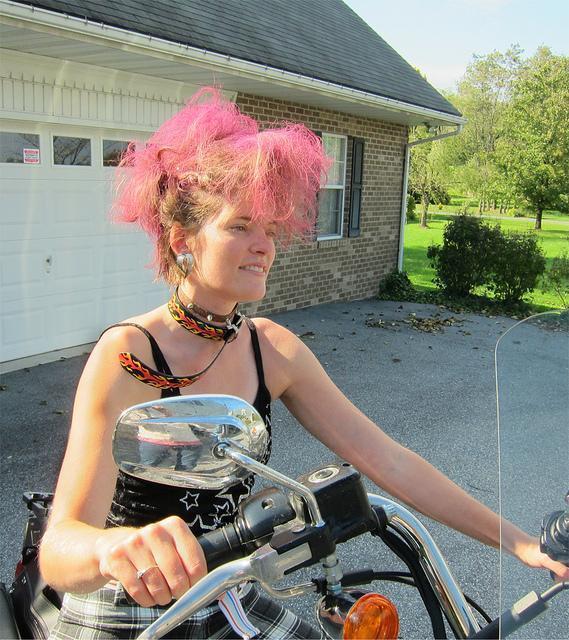How many of the boats in the front have yellow poles?
Give a very brief answer. 0. 